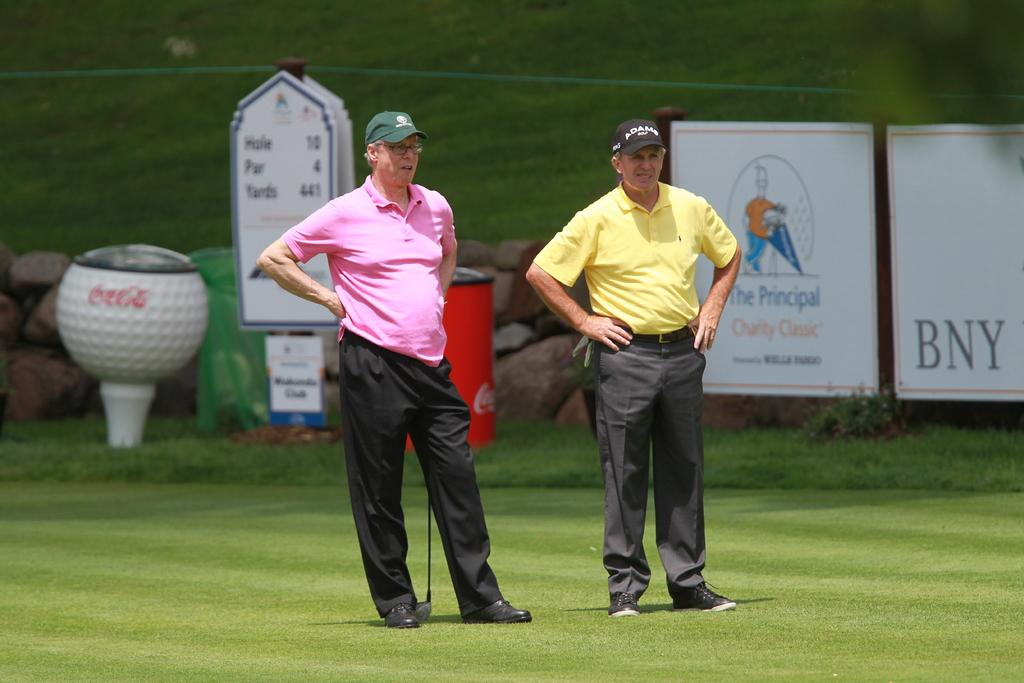How many people are in the image? There are two persons in the image. What are the persons standing on? The persons are standing on the grass. What are the persons holding in their hands? The persons are holding golf sticks. What can be seen on the boards in the image? There are boards with text in the image. What is the color of the white object in the image? There is a white color object in the image. What type of natural elements can be seen in the image? There are stones in the image. What type of cushion is being used by the persons in the image? There is no cushion present in the image. 